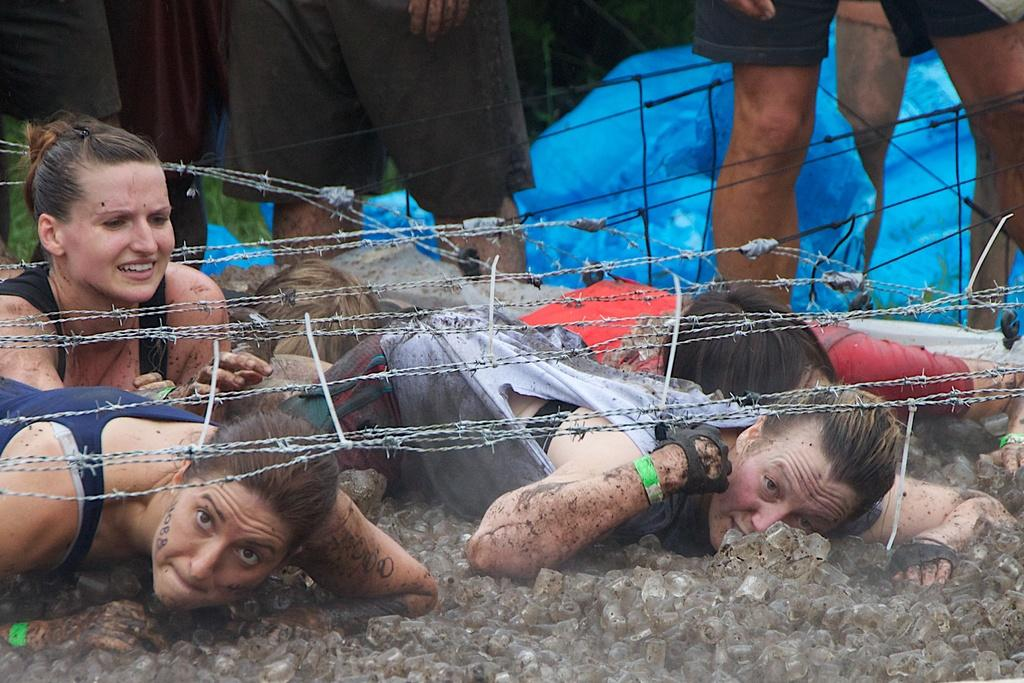What are the persons in the image wearing? The persons in the image are wearing clothes. Where are the persons located in relation to the fencing wires? The persons are under the fencing wires in the image. What type of stove can be seen in the image? There is no stove present in the image. How many chairs are visible in the image? There are no chairs visible in the image. 